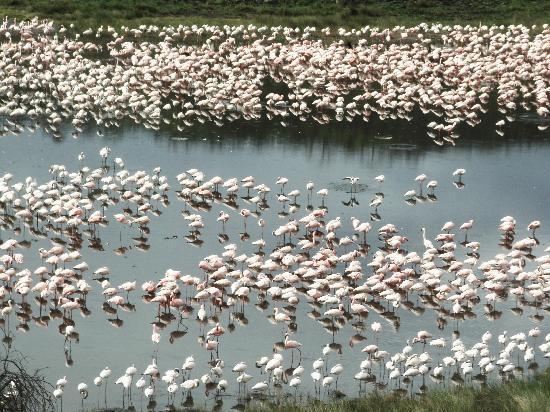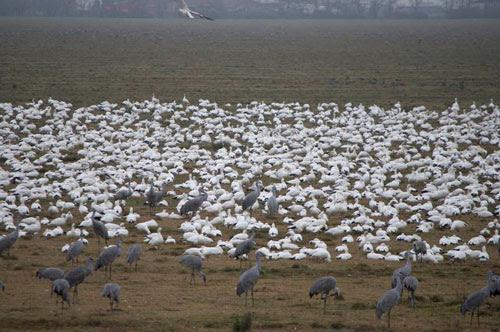The first image is the image on the left, the second image is the image on the right. Evaluate the accuracy of this statement regarding the images: "The left image includes a body of water with some birds in the water.". Is it true? Answer yes or no. Yes. The first image is the image on the left, the second image is the image on the right. For the images displayed, is the sentence "There are at least 100 white bird sitting on the ground with at least 2 gray crane walking across the field." factually correct? Answer yes or no. Yes. 